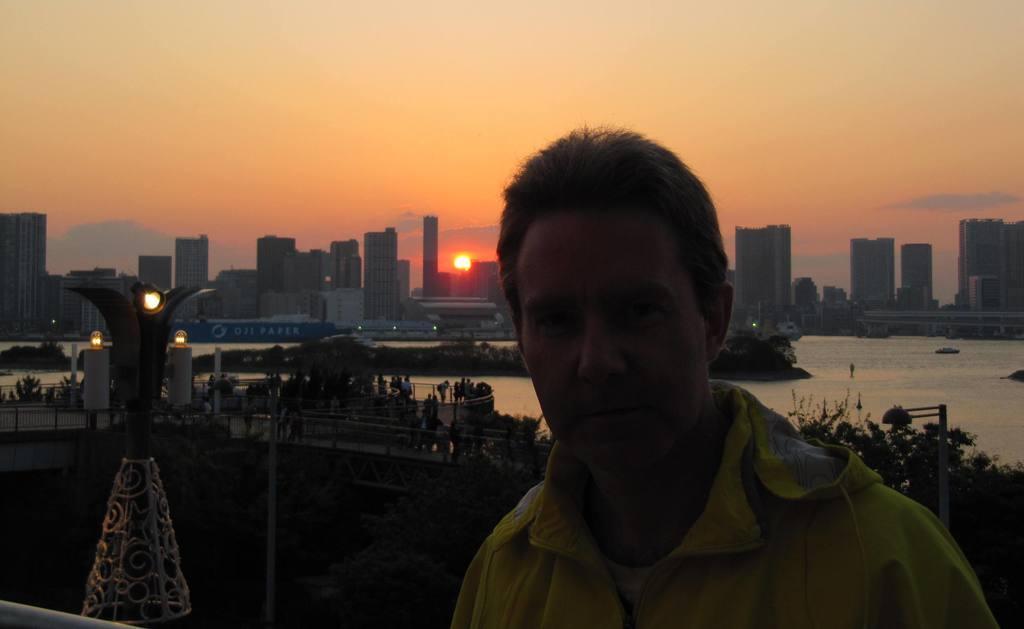Can you describe this image briefly? This is an outside view. On the right side there is a man wearing a jacket and looking at the picture. On the left side there is a bridge on which I can see some people. On the right side there are some trees and a light pole and also there is a sea. In the background there are many buildings. At the top of the image I can see the sky along with the sun. 